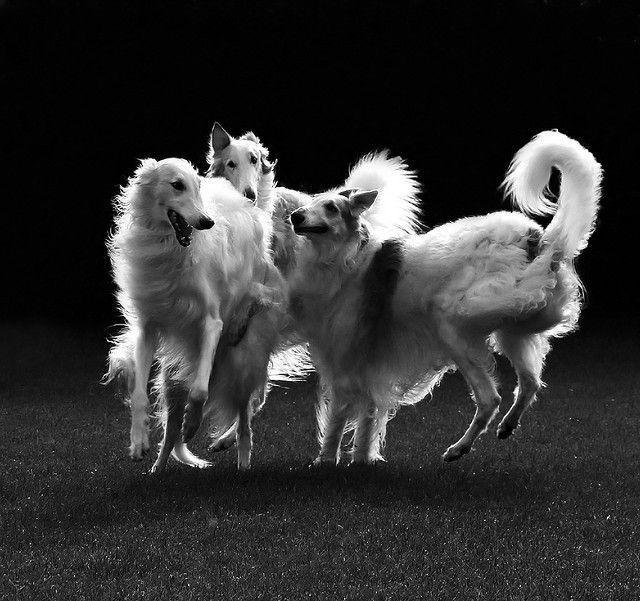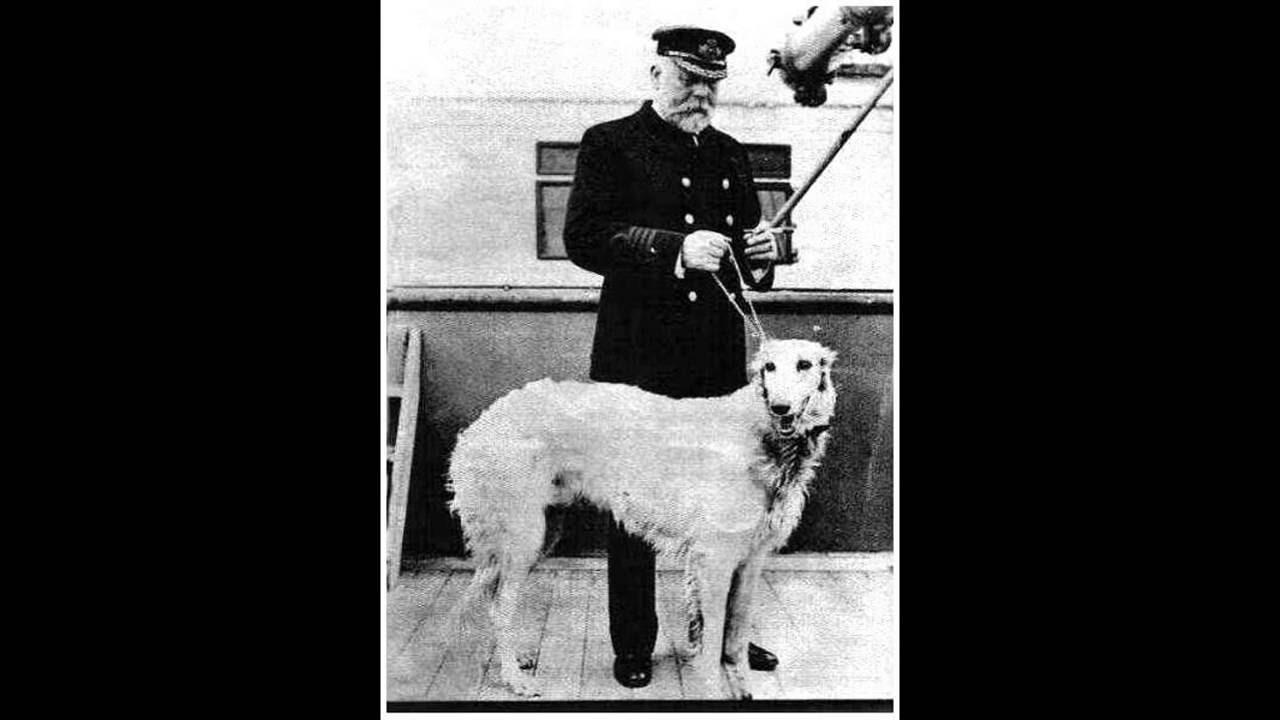The first image is the image on the left, the second image is the image on the right. Examine the images to the left and right. Is the description "Each image contains exactly one hound, and the dogs in the left and right images share similar fur coloring and body poses." accurate? Answer yes or no. No. The first image is the image on the left, the second image is the image on the right. For the images displayed, is the sentence "the left and right image contains the same number of dogs." factually correct? Answer yes or no. No. 